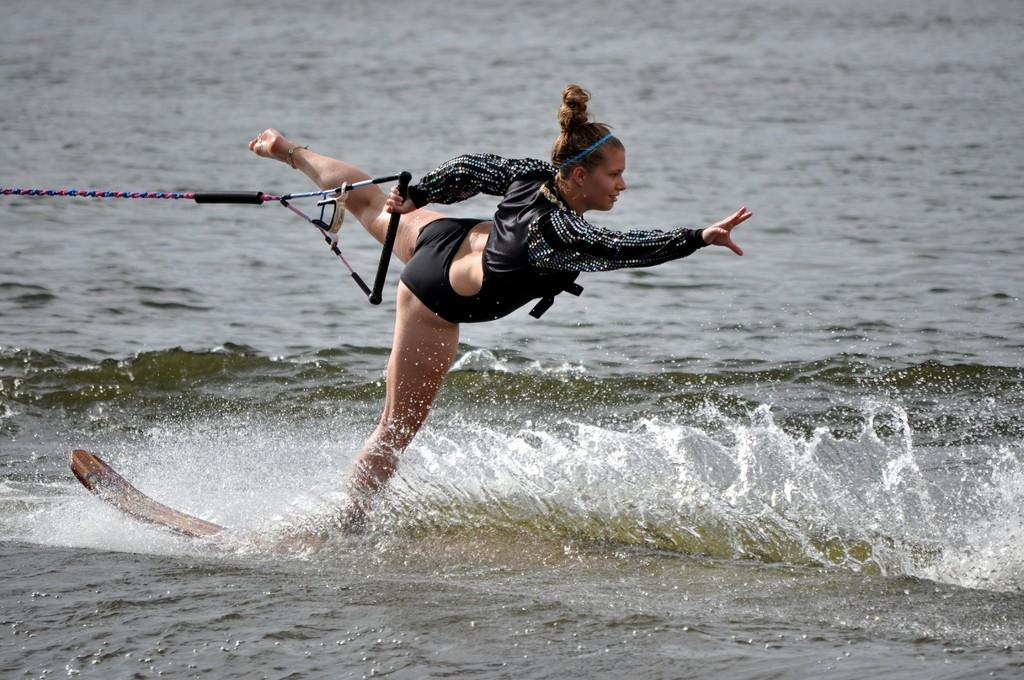Who is the main subject in the image? There is a woman in the image. What is the woman doing in the image? The woman is on a surfboard. What is the woman holding in the image? The woman is holding a rope. What type of environment is visible in the image? There is water visible in the image. What type of reward does the woman receive for flying in the image? There is no indication in the image that the woman is flying or receiving any rewards. 